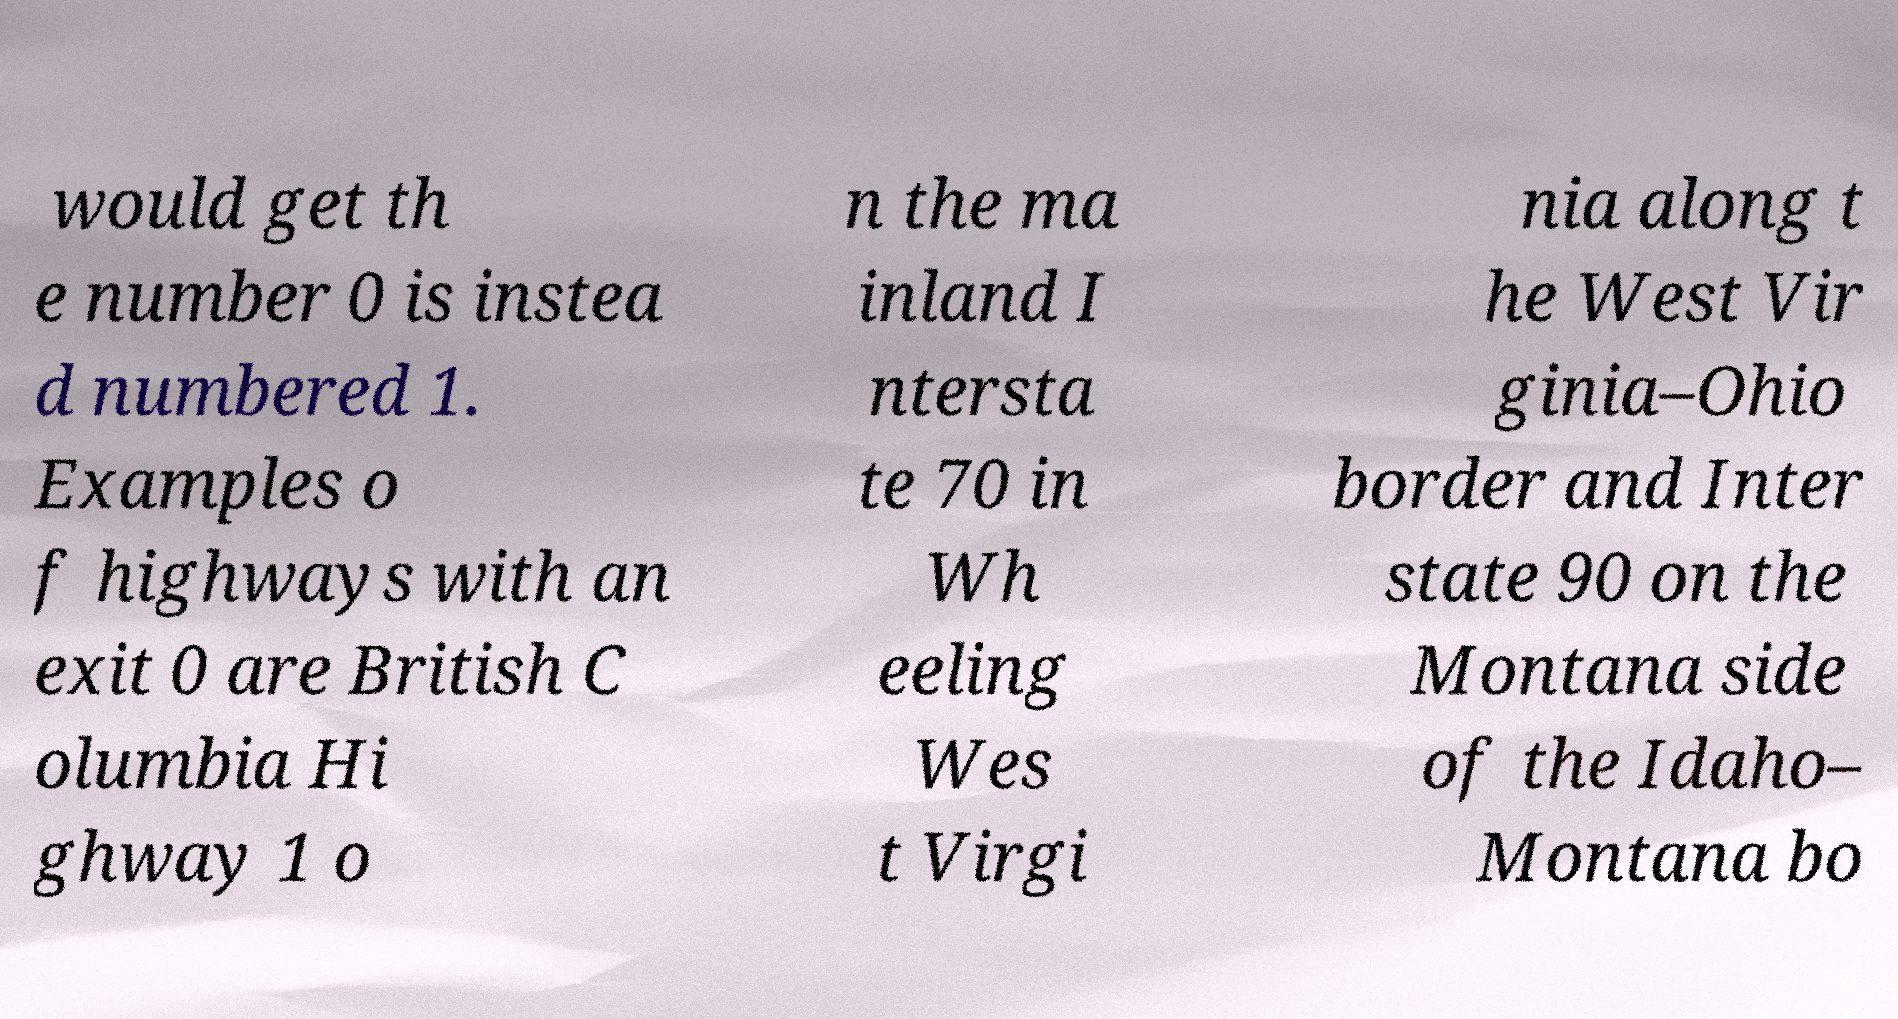I need the written content from this picture converted into text. Can you do that? would get th e number 0 is instea d numbered 1. Examples o f highways with an exit 0 are British C olumbia Hi ghway 1 o n the ma inland I ntersta te 70 in Wh eeling Wes t Virgi nia along t he West Vir ginia–Ohio border and Inter state 90 on the Montana side of the Idaho– Montana bo 